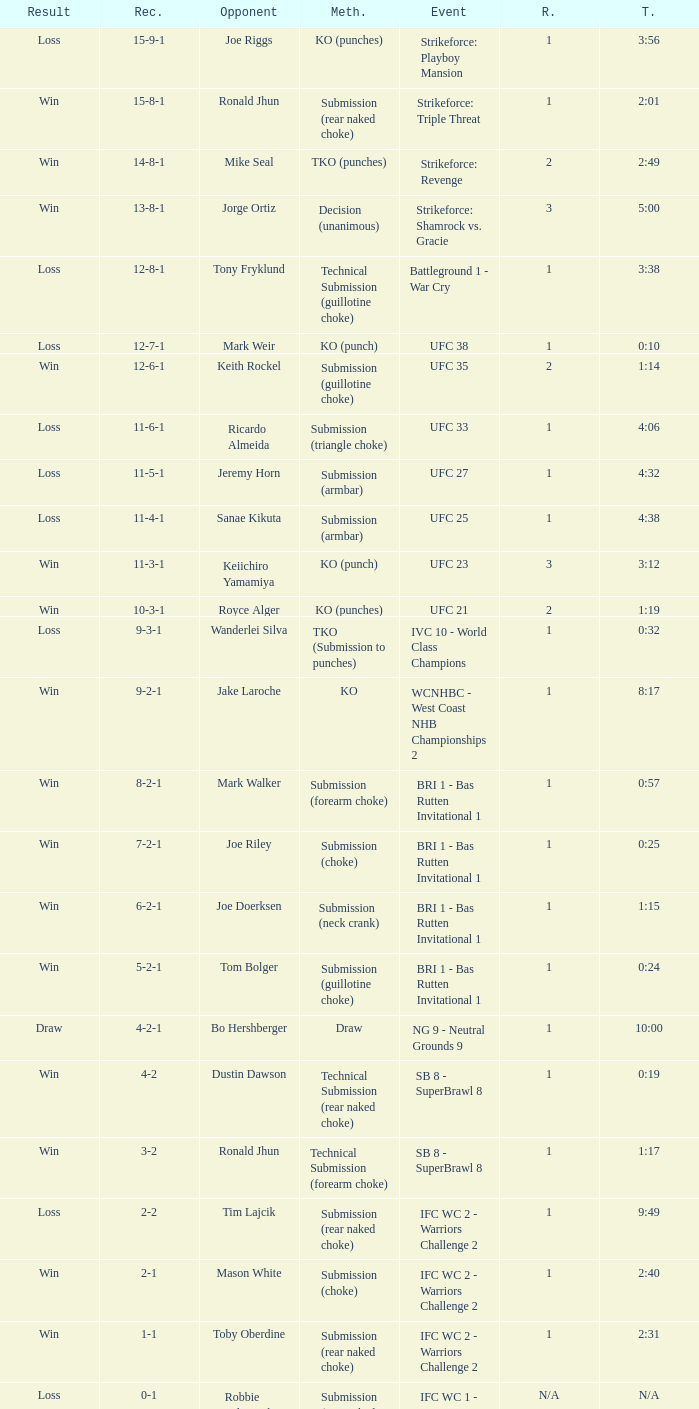Would you be able to parse every entry in this table? {'header': ['Result', 'Rec.', 'Opponent', 'Meth.', 'Event', 'R.', 'T.'], 'rows': [['Loss', '15-9-1', 'Joe Riggs', 'KO (punches)', 'Strikeforce: Playboy Mansion', '1', '3:56'], ['Win', '15-8-1', 'Ronald Jhun', 'Submission (rear naked choke)', 'Strikeforce: Triple Threat', '1', '2:01'], ['Win', '14-8-1', 'Mike Seal', 'TKO (punches)', 'Strikeforce: Revenge', '2', '2:49'], ['Win', '13-8-1', 'Jorge Ortiz', 'Decision (unanimous)', 'Strikeforce: Shamrock vs. Gracie', '3', '5:00'], ['Loss', '12-8-1', 'Tony Fryklund', 'Technical Submission (guillotine choke)', 'Battleground 1 - War Cry', '1', '3:38'], ['Loss', '12-7-1', 'Mark Weir', 'KO (punch)', 'UFC 38', '1', '0:10'], ['Win', '12-6-1', 'Keith Rockel', 'Submission (guillotine choke)', 'UFC 35', '2', '1:14'], ['Loss', '11-6-1', 'Ricardo Almeida', 'Submission (triangle choke)', 'UFC 33', '1', '4:06'], ['Loss', '11-5-1', 'Jeremy Horn', 'Submission (armbar)', 'UFC 27', '1', '4:32'], ['Loss', '11-4-1', 'Sanae Kikuta', 'Submission (armbar)', 'UFC 25', '1', '4:38'], ['Win', '11-3-1', 'Keiichiro Yamamiya', 'KO (punch)', 'UFC 23', '3', '3:12'], ['Win', '10-3-1', 'Royce Alger', 'KO (punches)', 'UFC 21', '2', '1:19'], ['Loss', '9-3-1', 'Wanderlei Silva', 'TKO (Submission to punches)', 'IVC 10 - World Class Champions', '1', '0:32'], ['Win', '9-2-1', 'Jake Laroche', 'KO', 'WCNHBC - West Coast NHB Championships 2', '1', '8:17'], ['Win', '8-2-1', 'Mark Walker', 'Submission (forearm choke)', 'BRI 1 - Bas Rutten Invitational 1', '1', '0:57'], ['Win', '7-2-1', 'Joe Riley', 'Submission (choke)', 'BRI 1 - Bas Rutten Invitational 1', '1', '0:25'], ['Win', '6-2-1', 'Joe Doerksen', 'Submission (neck crank)', 'BRI 1 - Bas Rutten Invitational 1', '1', '1:15'], ['Win', '5-2-1', 'Tom Bolger', 'Submission (guillotine choke)', 'BRI 1 - Bas Rutten Invitational 1', '1', '0:24'], ['Draw', '4-2-1', 'Bo Hershberger', 'Draw', 'NG 9 - Neutral Grounds 9', '1', '10:00'], ['Win', '4-2', 'Dustin Dawson', 'Technical Submission (rear naked choke)', 'SB 8 - SuperBrawl 8', '1', '0:19'], ['Win', '3-2', 'Ronald Jhun', 'Technical Submission (forearm choke)', 'SB 8 - SuperBrawl 8', '1', '1:17'], ['Loss', '2-2', 'Tim Lajcik', 'Submission (rear naked choke)', 'IFC WC 2 - Warriors Challenge 2', '1', '9:49'], ['Win', '2-1', 'Mason White', 'Submission (choke)', 'IFC WC 2 - Warriors Challenge 2', '1', '2:40'], ['Win', '1-1', 'Toby Oberdine', 'Submission (rear naked choke)', 'IFC WC 2 - Warriors Challenge 2', '1', '2:31'], ['Loss', '0-1', 'Robbie Kilpatrick', 'Submission (rear naked choke)', 'IFC WC 1 - Warriors Challenge 1', 'N/A', 'N/A']]} What is the result when the combat was against keith rockel? 12-6-1. 